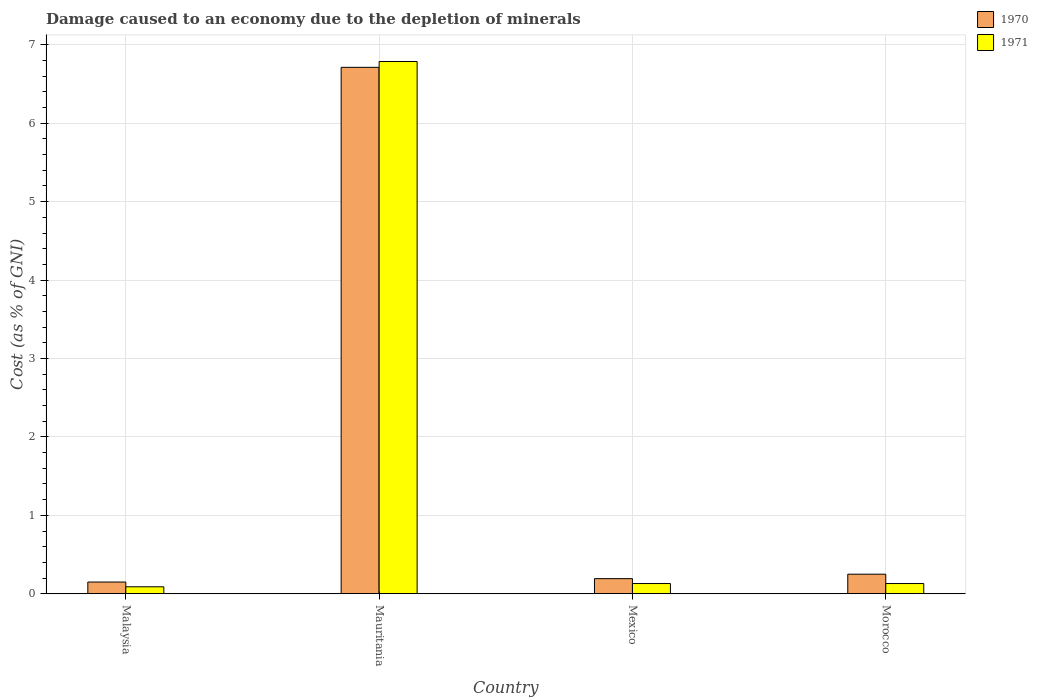Are the number of bars per tick equal to the number of legend labels?
Keep it short and to the point. Yes. Are the number of bars on each tick of the X-axis equal?
Provide a short and direct response. Yes. In how many cases, is the number of bars for a given country not equal to the number of legend labels?
Keep it short and to the point. 0. What is the cost of damage caused due to the depletion of minerals in 1971 in Mauritania?
Keep it short and to the point. 6.79. Across all countries, what is the maximum cost of damage caused due to the depletion of minerals in 1970?
Keep it short and to the point. 6.71. Across all countries, what is the minimum cost of damage caused due to the depletion of minerals in 1971?
Keep it short and to the point. 0.09. In which country was the cost of damage caused due to the depletion of minerals in 1970 maximum?
Give a very brief answer. Mauritania. In which country was the cost of damage caused due to the depletion of minerals in 1970 minimum?
Your response must be concise. Malaysia. What is the total cost of damage caused due to the depletion of minerals in 1970 in the graph?
Keep it short and to the point. 7.3. What is the difference between the cost of damage caused due to the depletion of minerals in 1971 in Mexico and that in Morocco?
Provide a short and direct response. 5.168240398312207e-5. What is the difference between the cost of damage caused due to the depletion of minerals in 1970 in Mexico and the cost of damage caused due to the depletion of minerals in 1971 in Mauritania?
Provide a succinct answer. -6.59. What is the average cost of damage caused due to the depletion of minerals in 1970 per country?
Ensure brevity in your answer.  1.83. What is the difference between the cost of damage caused due to the depletion of minerals of/in 1970 and cost of damage caused due to the depletion of minerals of/in 1971 in Malaysia?
Your answer should be compact. 0.06. What is the ratio of the cost of damage caused due to the depletion of minerals in 1971 in Mexico to that in Morocco?
Your answer should be very brief. 1. Is the cost of damage caused due to the depletion of minerals in 1971 in Malaysia less than that in Morocco?
Provide a succinct answer. Yes. Is the difference between the cost of damage caused due to the depletion of minerals in 1970 in Malaysia and Mexico greater than the difference between the cost of damage caused due to the depletion of minerals in 1971 in Malaysia and Mexico?
Your response must be concise. No. What is the difference between the highest and the second highest cost of damage caused due to the depletion of minerals in 1970?
Offer a very short reply. 0.06. What is the difference between the highest and the lowest cost of damage caused due to the depletion of minerals in 1970?
Give a very brief answer. 6.56. In how many countries, is the cost of damage caused due to the depletion of minerals in 1971 greater than the average cost of damage caused due to the depletion of minerals in 1971 taken over all countries?
Give a very brief answer. 1. What does the 2nd bar from the left in Malaysia represents?
Make the answer very short. 1971. Are all the bars in the graph horizontal?
Keep it short and to the point. No. How many countries are there in the graph?
Provide a succinct answer. 4. Does the graph contain grids?
Offer a terse response. Yes. What is the title of the graph?
Your answer should be very brief. Damage caused to an economy due to the depletion of minerals. What is the label or title of the X-axis?
Your answer should be compact. Country. What is the label or title of the Y-axis?
Your response must be concise. Cost (as % of GNI). What is the Cost (as % of GNI) in 1970 in Malaysia?
Give a very brief answer. 0.15. What is the Cost (as % of GNI) in 1971 in Malaysia?
Ensure brevity in your answer.  0.09. What is the Cost (as % of GNI) in 1970 in Mauritania?
Ensure brevity in your answer.  6.71. What is the Cost (as % of GNI) in 1971 in Mauritania?
Make the answer very short. 6.79. What is the Cost (as % of GNI) of 1970 in Mexico?
Keep it short and to the point. 0.19. What is the Cost (as % of GNI) of 1971 in Mexico?
Your response must be concise. 0.13. What is the Cost (as % of GNI) in 1970 in Morocco?
Your response must be concise. 0.25. What is the Cost (as % of GNI) of 1971 in Morocco?
Provide a short and direct response. 0.13. Across all countries, what is the maximum Cost (as % of GNI) in 1970?
Provide a succinct answer. 6.71. Across all countries, what is the maximum Cost (as % of GNI) of 1971?
Give a very brief answer. 6.79. Across all countries, what is the minimum Cost (as % of GNI) of 1970?
Give a very brief answer. 0.15. Across all countries, what is the minimum Cost (as % of GNI) of 1971?
Your answer should be very brief. 0.09. What is the total Cost (as % of GNI) of 1970 in the graph?
Give a very brief answer. 7.3. What is the total Cost (as % of GNI) of 1971 in the graph?
Ensure brevity in your answer.  7.14. What is the difference between the Cost (as % of GNI) in 1970 in Malaysia and that in Mauritania?
Your answer should be compact. -6.56. What is the difference between the Cost (as % of GNI) of 1971 in Malaysia and that in Mauritania?
Offer a very short reply. -6.7. What is the difference between the Cost (as % of GNI) in 1970 in Malaysia and that in Mexico?
Provide a short and direct response. -0.04. What is the difference between the Cost (as % of GNI) in 1971 in Malaysia and that in Mexico?
Make the answer very short. -0.04. What is the difference between the Cost (as % of GNI) of 1971 in Malaysia and that in Morocco?
Provide a short and direct response. -0.04. What is the difference between the Cost (as % of GNI) in 1970 in Mauritania and that in Mexico?
Your response must be concise. 6.52. What is the difference between the Cost (as % of GNI) of 1971 in Mauritania and that in Mexico?
Your answer should be very brief. 6.66. What is the difference between the Cost (as % of GNI) of 1970 in Mauritania and that in Morocco?
Provide a short and direct response. 6.46. What is the difference between the Cost (as % of GNI) of 1971 in Mauritania and that in Morocco?
Your answer should be very brief. 6.66. What is the difference between the Cost (as % of GNI) in 1970 in Mexico and that in Morocco?
Your answer should be very brief. -0.06. What is the difference between the Cost (as % of GNI) in 1971 in Mexico and that in Morocco?
Offer a very short reply. 0. What is the difference between the Cost (as % of GNI) of 1970 in Malaysia and the Cost (as % of GNI) of 1971 in Mauritania?
Your answer should be very brief. -6.64. What is the difference between the Cost (as % of GNI) in 1970 in Malaysia and the Cost (as % of GNI) in 1971 in Mexico?
Offer a terse response. 0.02. What is the difference between the Cost (as % of GNI) in 1970 in Malaysia and the Cost (as % of GNI) in 1971 in Morocco?
Offer a terse response. 0.02. What is the difference between the Cost (as % of GNI) of 1970 in Mauritania and the Cost (as % of GNI) of 1971 in Mexico?
Give a very brief answer. 6.58. What is the difference between the Cost (as % of GNI) in 1970 in Mauritania and the Cost (as % of GNI) in 1971 in Morocco?
Provide a succinct answer. 6.58. What is the difference between the Cost (as % of GNI) of 1970 in Mexico and the Cost (as % of GNI) of 1971 in Morocco?
Give a very brief answer. 0.06. What is the average Cost (as % of GNI) of 1970 per country?
Provide a succinct answer. 1.83. What is the average Cost (as % of GNI) of 1971 per country?
Your answer should be very brief. 1.78. What is the difference between the Cost (as % of GNI) in 1970 and Cost (as % of GNI) in 1971 in Malaysia?
Offer a very short reply. 0.06. What is the difference between the Cost (as % of GNI) of 1970 and Cost (as % of GNI) of 1971 in Mauritania?
Make the answer very short. -0.07. What is the difference between the Cost (as % of GNI) of 1970 and Cost (as % of GNI) of 1971 in Mexico?
Provide a short and direct response. 0.06. What is the difference between the Cost (as % of GNI) of 1970 and Cost (as % of GNI) of 1971 in Morocco?
Offer a very short reply. 0.12. What is the ratio of the Cost (as % of GNI) in 1970 in Malaysia to that in Mauritania?
Give a very brief answer. 0.02. What is the ratio of the Cost (as % of GNI) in 1971 in Malaysia to that in Mauritania?
Ensure brevity in your answer.  0.01. What is the ratio of the Cost (as % of GNI) in 1970 in Malaysia to that in Mexico?
Your answer should be very brief. 0.77. What is the ratio of the Cost (as % of GNI) of 1971 in Malaysia to that in Mexico?
Ensure brevity in your answer.  0.68. What is the ratio of the Cost (as % of GNI) of 1970 in Malaysia to that in Morocco?
Give a very brief answer. 0.6. What is the ratio of the Cost (as % of GNI) of 1971 in Malaysia to that in Morocco?
Your answer should be compact. 0.68. What is the ratio of the Cost (as % of GNI) of 1970 in Mauritania to that in Mexico?
Give a very brief answer. 34.85. What is the ratio of the Cost (as % of GNI) of 1971 in Mauritania to that in Mexico?
Offer a very short reply. 52.15. What is the ratio of the Cost (as % of GNI) in 1970 in Mauritania to that in Morocco?
Make the answer very short. 26.93. What is the ratio of the Cost (as % of GNI) of 1971 in Mauritania to that in Morocco?
Your response must be concise. 52.17. What is the ratio of the Cost (as % of GNI) in 1970 in Mexico to that in Morocco?
Keep it short and to the point. 0.77. What is the ratio of the Cost (as % of GNI) in 1971 in Mexico to that in Morocco?
Your answer should be compact. 1. What is the difference between the highest and the second highest Cost (as % of GNI) in 1970?
Keep it short and to the point. 6.46. What is the difference between the highest and the second highest Cost (as % of GNI) in 1971?
Give a very brief answer. 6.66. What is the difference between the highest and the lowest Cost (as % of GNI) of 1970?
Your response must be concise. 6.56. What is the difference between the highest and the lowest Cost (as % of GNI) of 1971?
Provide a succinct answer. 6.7. 